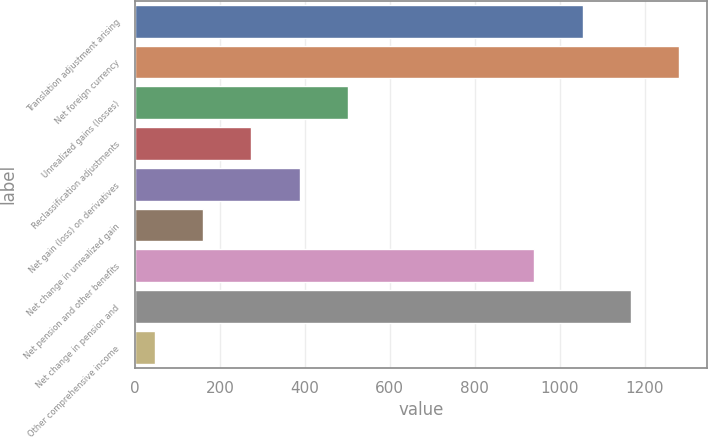Convert chart to OTSL. <chart><loc_0><loc_0><loc_500><loc_500><bar_chart><fcel>Translation adjustment arising<fcel>Net foreign currency<fcel>Unrealized gains (losses)<fcel>Reclassification adjustments<fcel>Net gain (loss) on derivatives<fcel>Net change in unrealized gain<fcel>Net pension and other benefits<fcel>Net change in pension and<fcel>Other comprehensive income<nl><fcel>1053.7<fcel>1281.1<fcel>501.8<fcel>274.4<fcel>388.1<fcel>160.7<fcel>940<fcel>1167.4<fcel>47<nl></chart> 